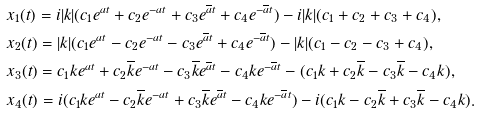<formula> <loc_0><loc_0><loc_500><loc_500>& x _ { 1 } ( t ) = i | k | ( c _ { 1 } e ^ { a t } + c _ { 2 } e ^ { - a t } + c _ { 3 } e ^ { \overline { a } t } + c _ { 4 } e ^ { - \overline { a } t } ) - i | k | ( c _ { 1 } + c _ { 2 } + c _ { 3 } + c _ { 4 } ) , \\ & x _ { 2 } ( t ) = | k | ( c _ { 1 } e ^ { a t } - c _ { 2 } e ^ { - a t } - c _ { 3 } e ^ { \overline { a } t } + c _ { 4 } e ^ { - \overline { a } t } ) - | k | ( c _ { 1 } - c _ { 2 } - c _ { 3 } + c _ { 4 } ) , \\ & x _ { 3 } ( t ) = c _ { 1 } k e ^ { a t } + c _ { 2 } \overline { k } e ^ { - a t } - c _ { 3 } \overline { k } e ^ { \overline { a } t } - c _ { 4 } k e ^ { - \overline { a } t } - ( c _ { 1 } k + c _ { 2 } \overline { k } - c _ { 3 } \overline { k } - c _ { 4 } k ) , \\ & x _ { 4 } ( t ) = i ( c _ { 1 } k e ^ { a t } - c _ { 2 } \overline { k } e ^ { - a t } + c _ { 3 } \overline { k } e ^ { \overline { a } t } - c _ { 4 } k e ^ { - \overline { a } t } ) - i ( c _ { 1 } k - c _ { 2 } \overline { k } + c _ { 3 } \overline { k } - c _ { 4 } k ) .</formula> 